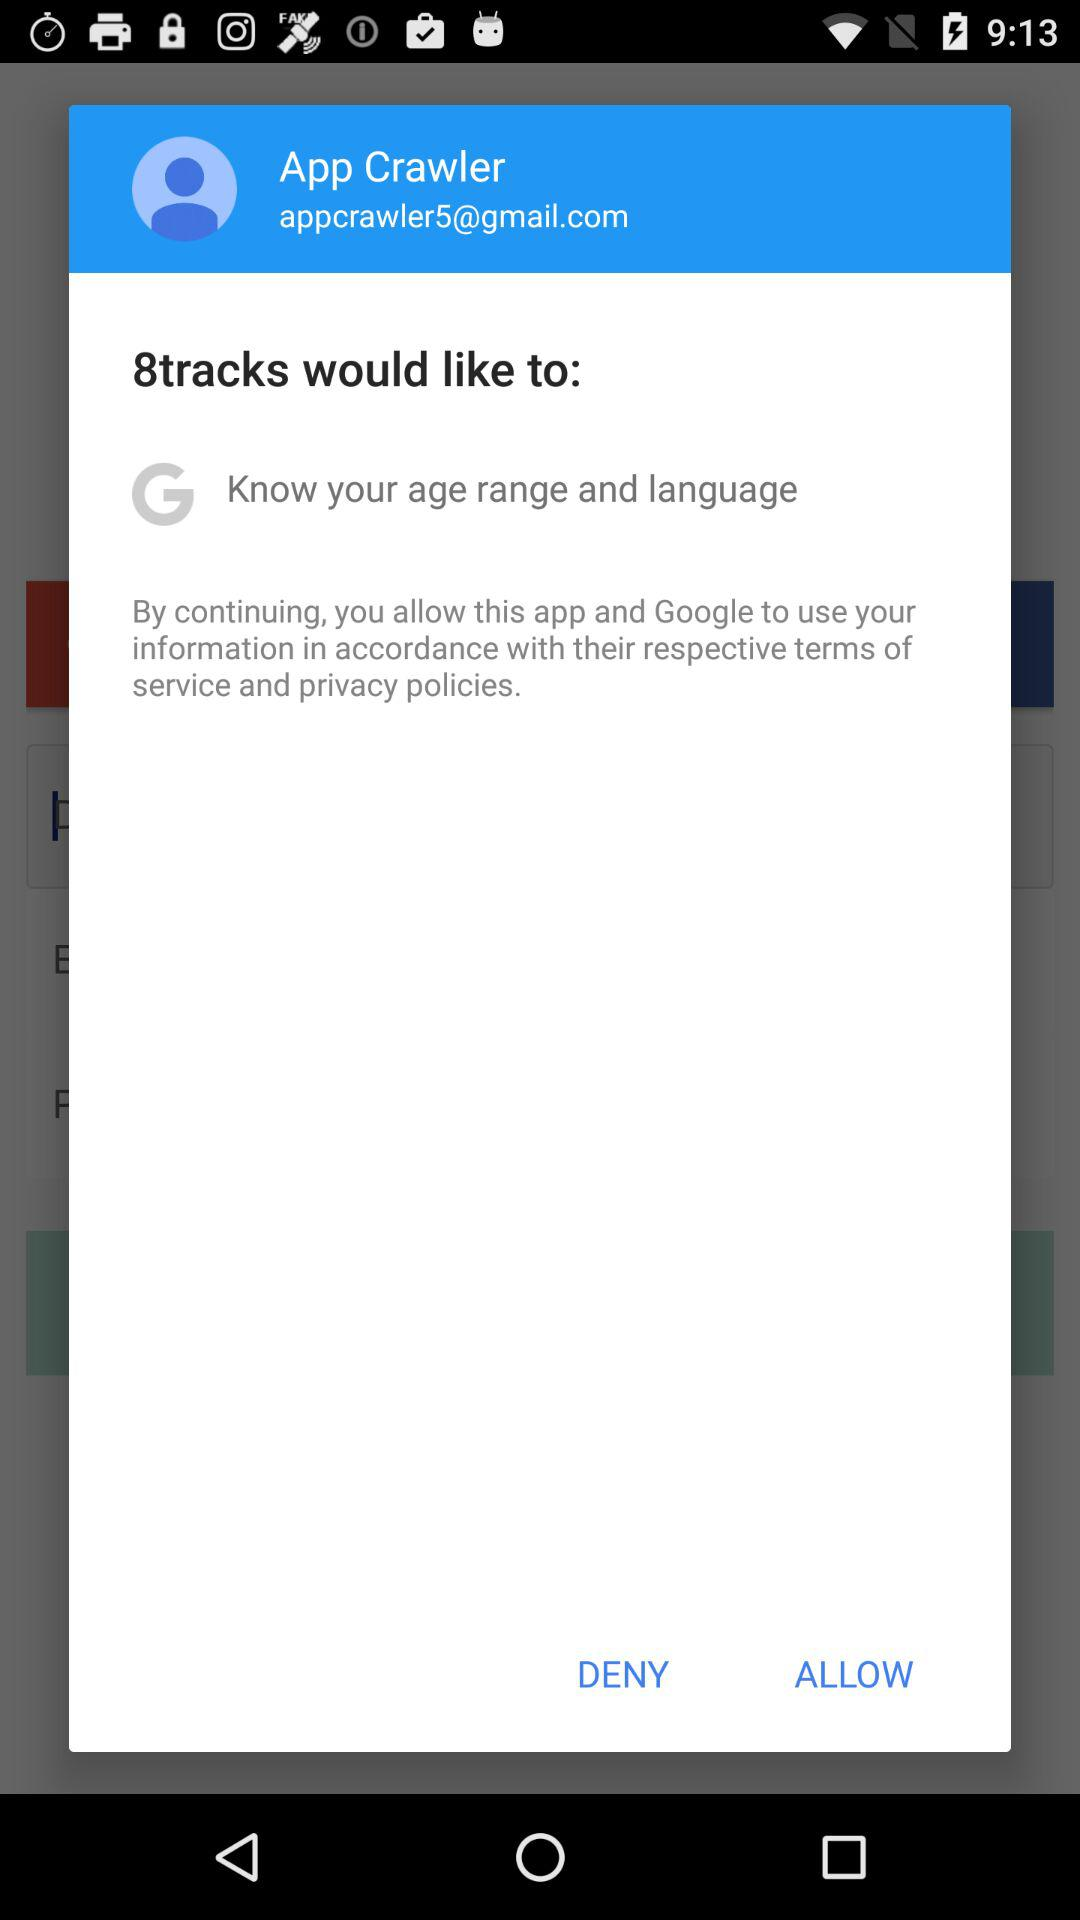What is the user name? The user name is "App Crawler". 